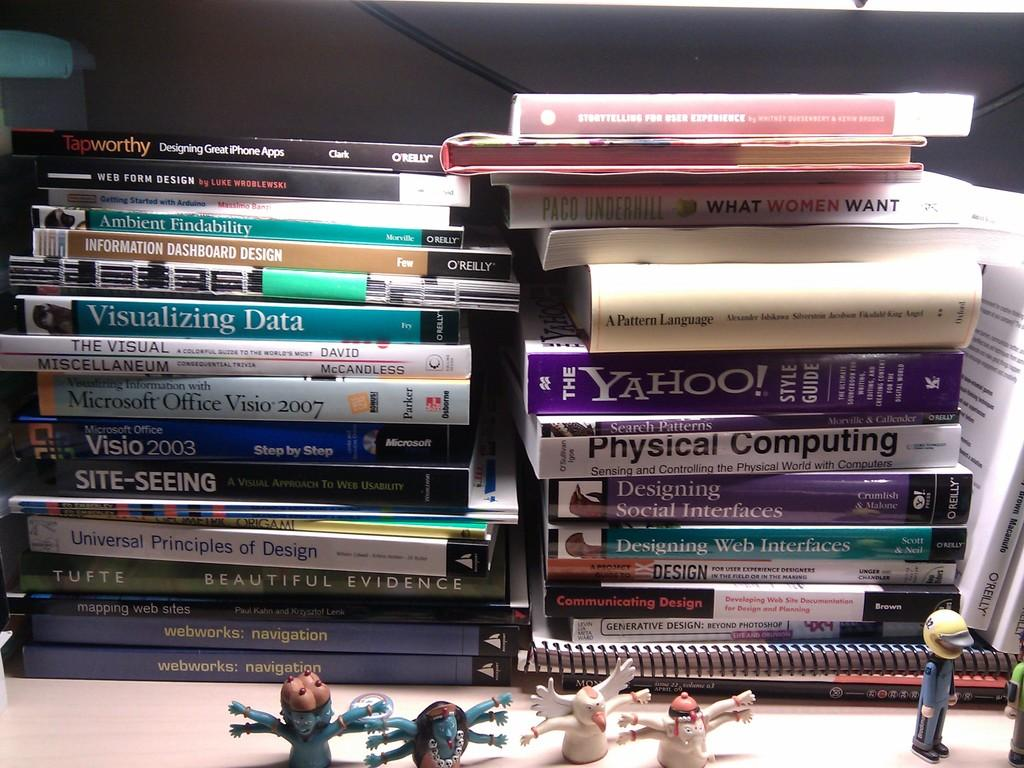<image>
Give a short and clear explanation of the subsequent image. Two large stacks of computer books sit on a desk including guides about visualizing data and physical computing. 